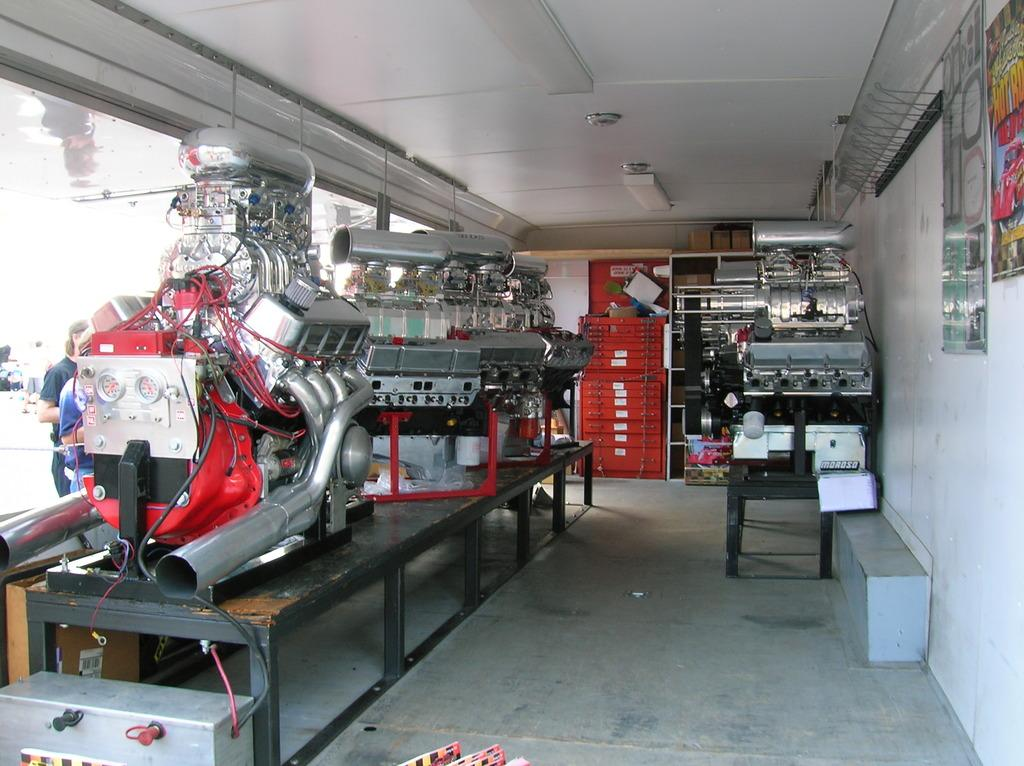What type of objects are on the tables in the image? There are machines on tables in the image. What can be seen on the wall in the image? There is a wall with objects attached to it in the image. What type of lighting is present in the image? There are lights on the ceiling in the image. Where else can machines be found in the image? There are machines on the floor in the image. What is the opinion of the river in the image? There is no river present in the image, so it is not possible to determine its opinion. 